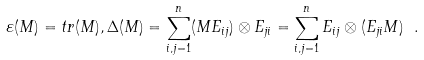<formula> <loc_0><loc_0><loc_500><loc_500>\varepsilon ( M ) = t r ( M ) , \Delta ( M ) = \sum _ { i , j = 1 } ^ { n } ( M E _ { i j } ) \otimes E _ { j i } = \sum _ { i , j = 1 } ^ { n } E _ { i j } \otimes ( E _ { j i } M ) \ .</formula> 